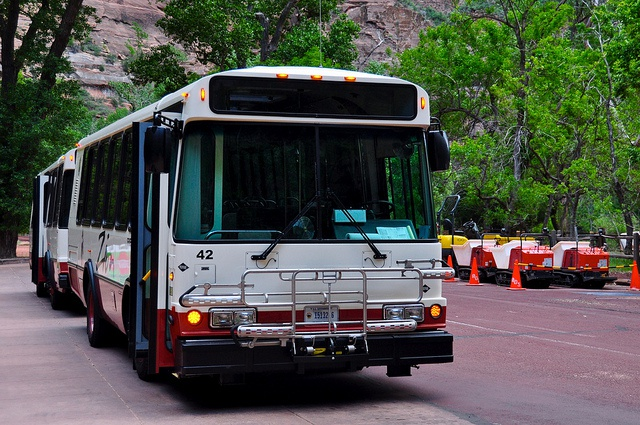Describe the objects in this image and their specific colors. I can see bus in black, darkgray, and gray tones and bus in black, darkgray, and gray tones in this image. 